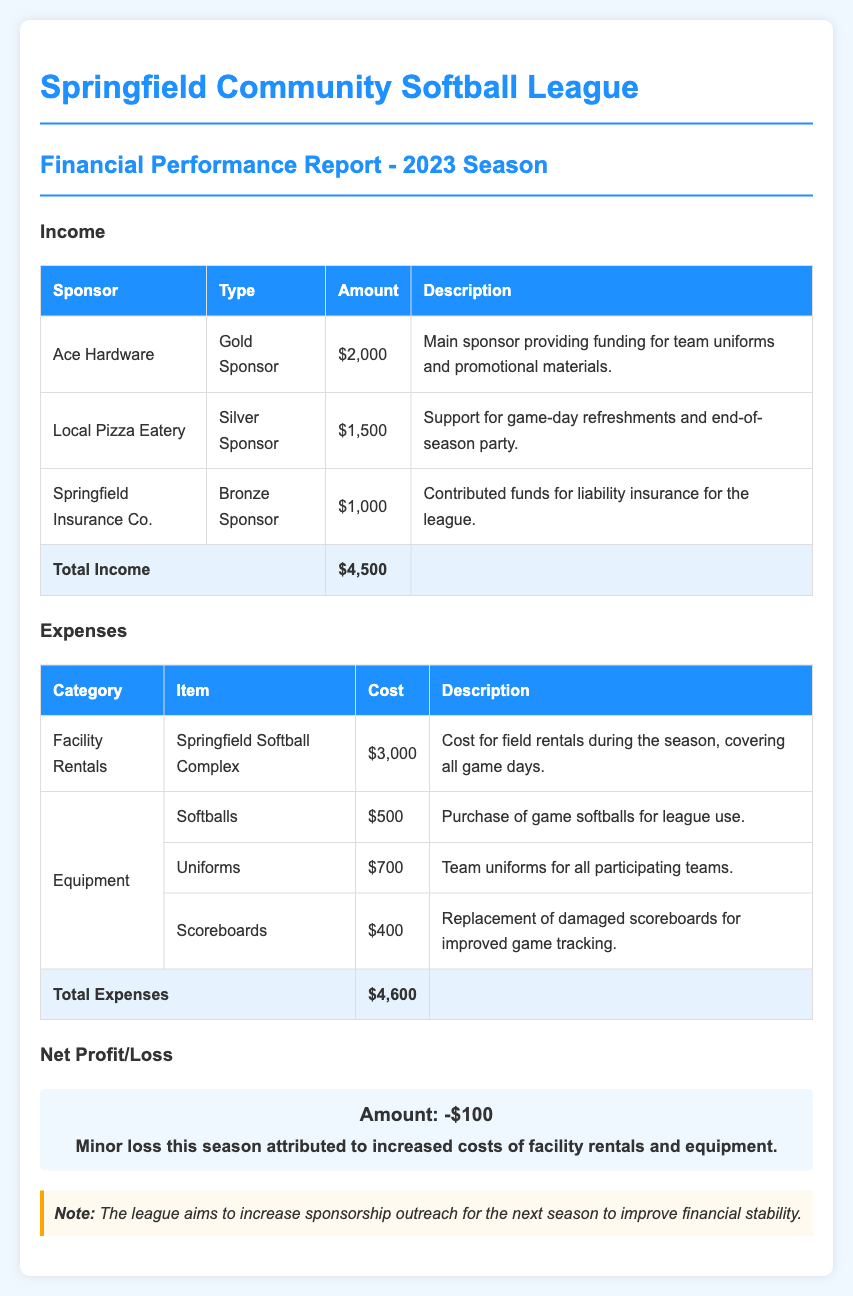What is the total income? The total income is the sum of all sponsorship amounts, which is $2,000 + $1,500 + $1,000 = $4,500.
Answer: $4,500 What was the cost of facility rentals? The cost of facility rentals is stated under expenses as $3,000 for the Springfield Softball Complex.
Answer: $3,000 Who is the main sponsor? The main sponsor is identified as Ace Hardware, contributing funding for team uniforms and promotional materials.
Answer: Ace Hardware What is the total expenses amount? The total expenses are listed as $4,600, summing all costs in the expenses section.
Answer: $4,600 What is the net profit or loss for the season? The net profit or loss is calculated as total income minus total expenses, resulting in a loss of $100.
Answer: -$100 How much was spent on uniforms? The cost spent on uniforms is specified in the equipment expenses as $700.
Answer: $700 What type of sponsorship did Springfield Insurance Co. provide? Springfield Insurance Co. is classified as a Bronze Sponsor in the income section.
Answer: Bronze Sponsor What is the description for Local Pizza Eatery's sponsorship? The description for Local Pizza Eatery's sponsorship indicates support for game-day refreshments and the end-of-season party.
Answer: Game-day refreshments and end-of-season party 